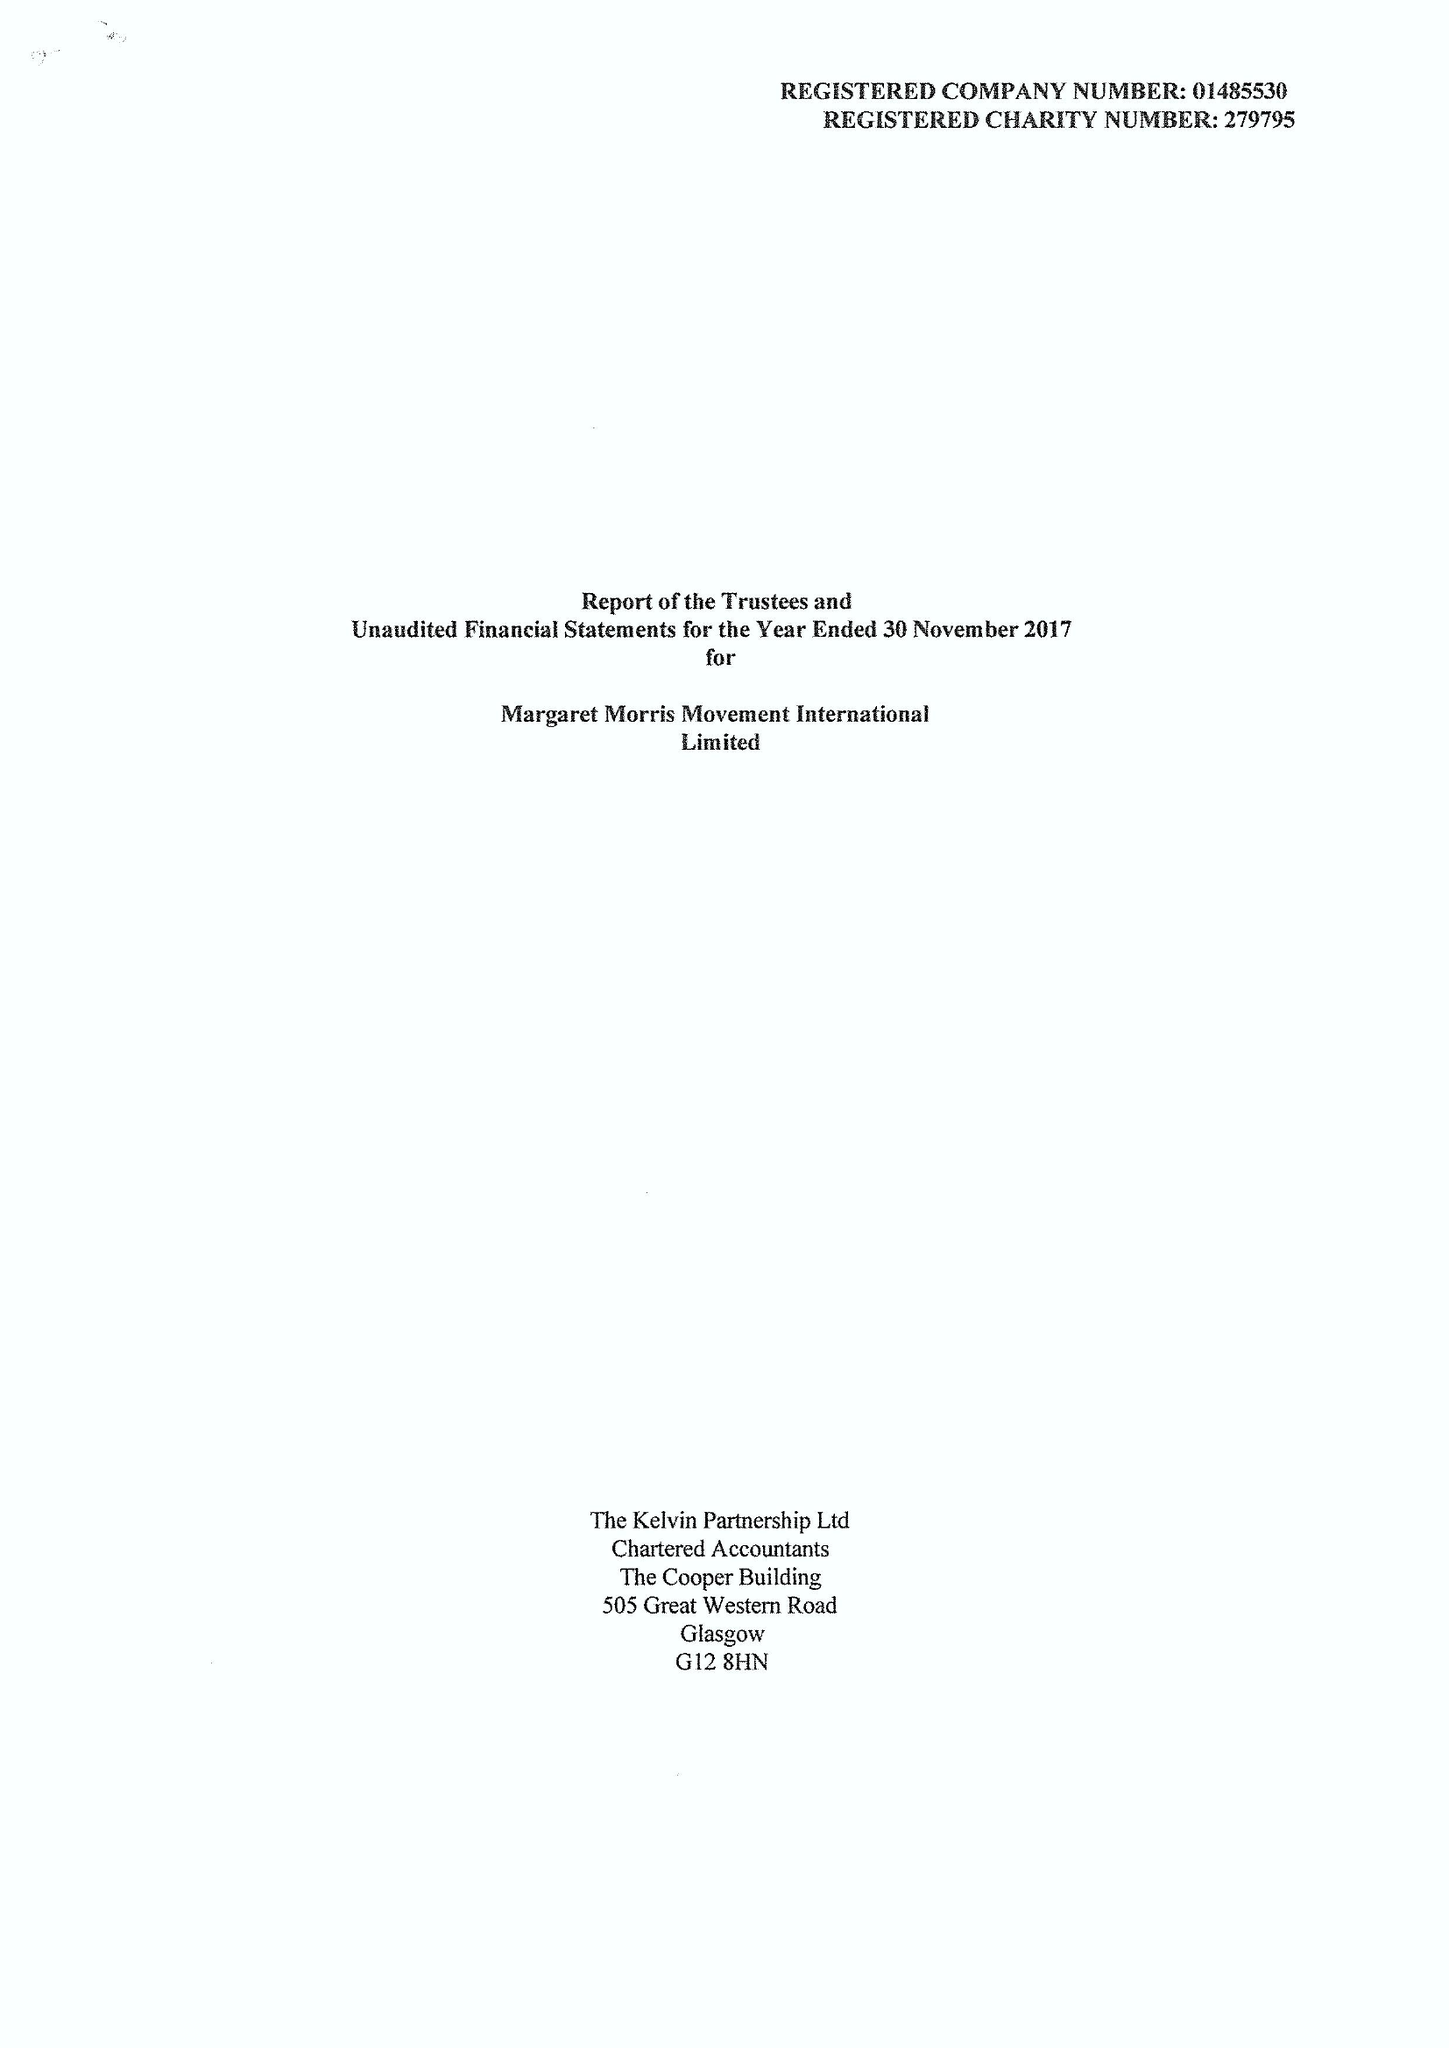What is the value for the address__postcode?
Answer the question using a single word or phrase. TF8 7DA 